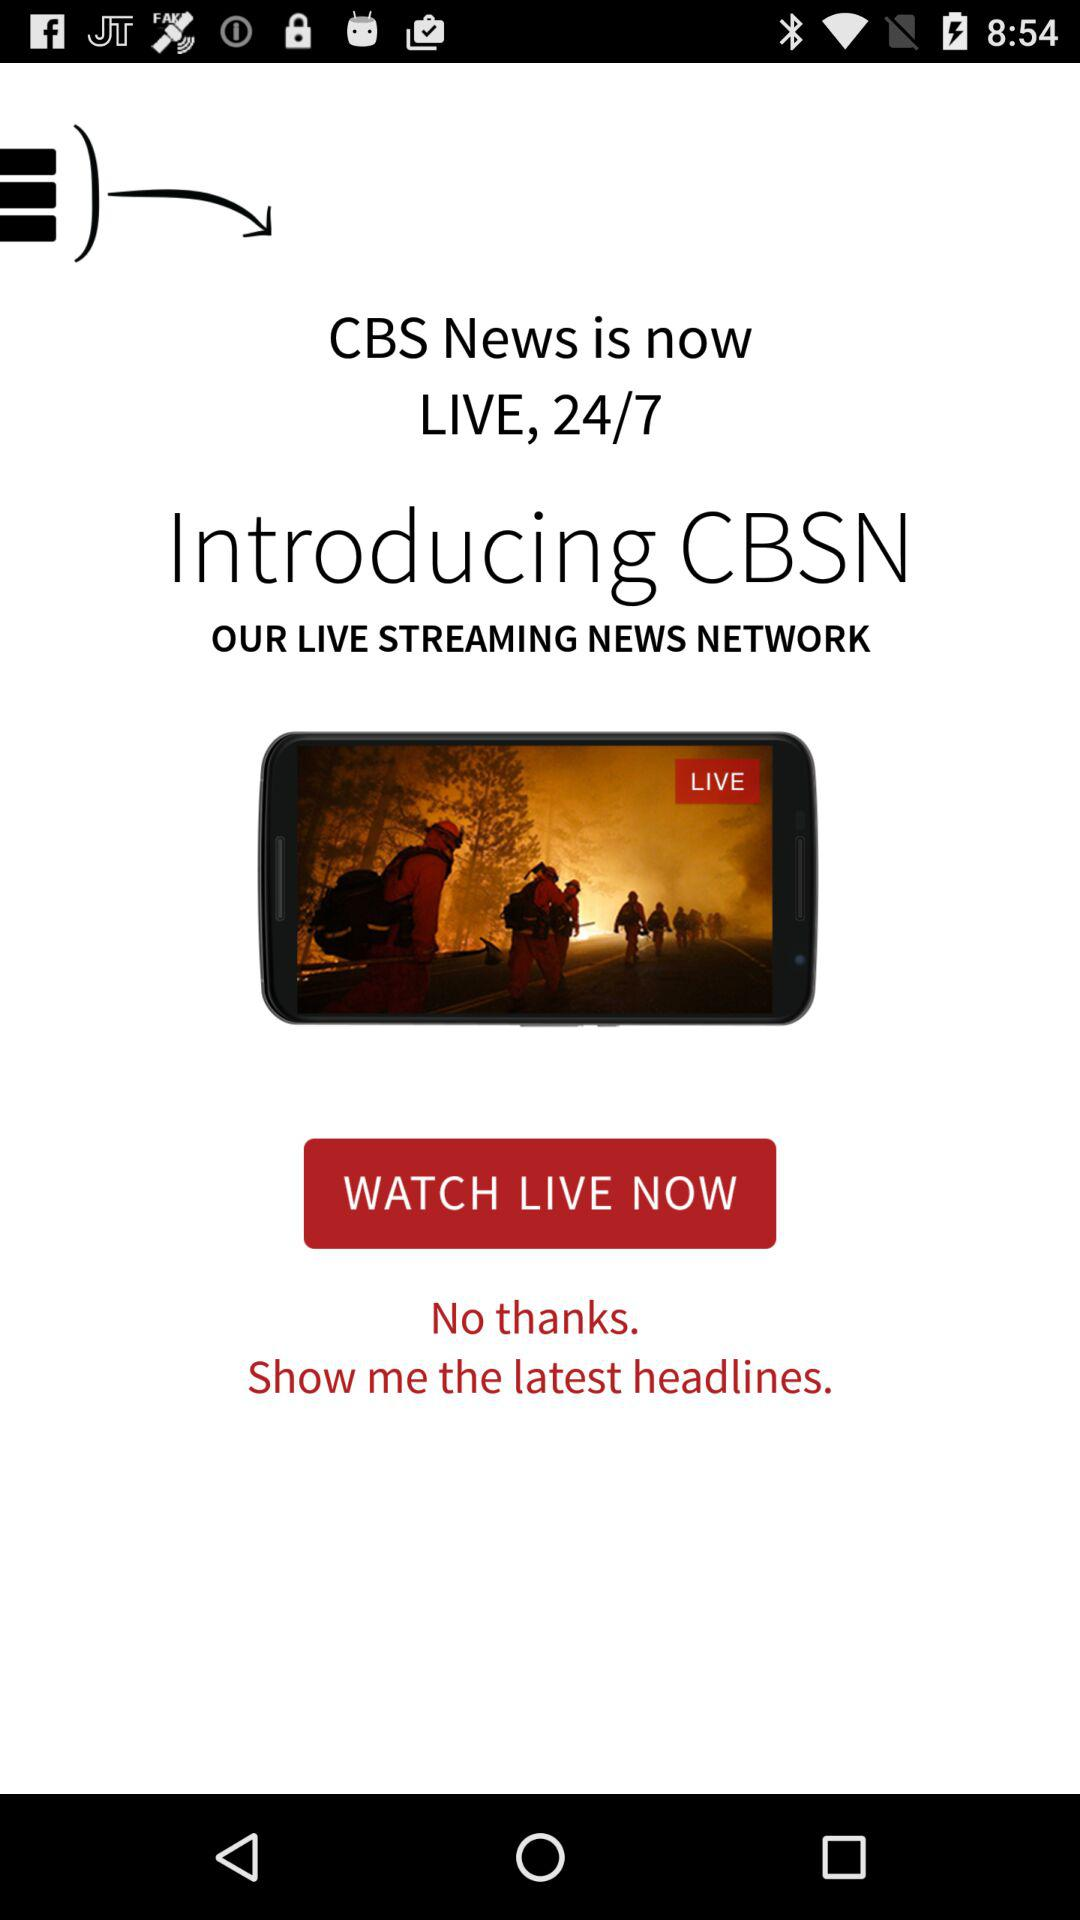What is the news channel name? The news channel name is CBSN. 